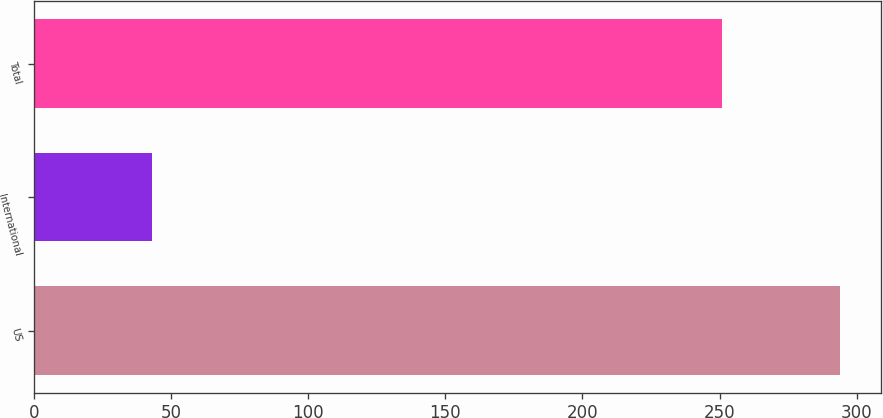<chart> <loc_0><loc_0><loc_500><loc_500><bar_chart><fcel>US<fcel>International<fcel>Total<nl><fcel>294<fcel>43<fcel>251<nl></chart> 